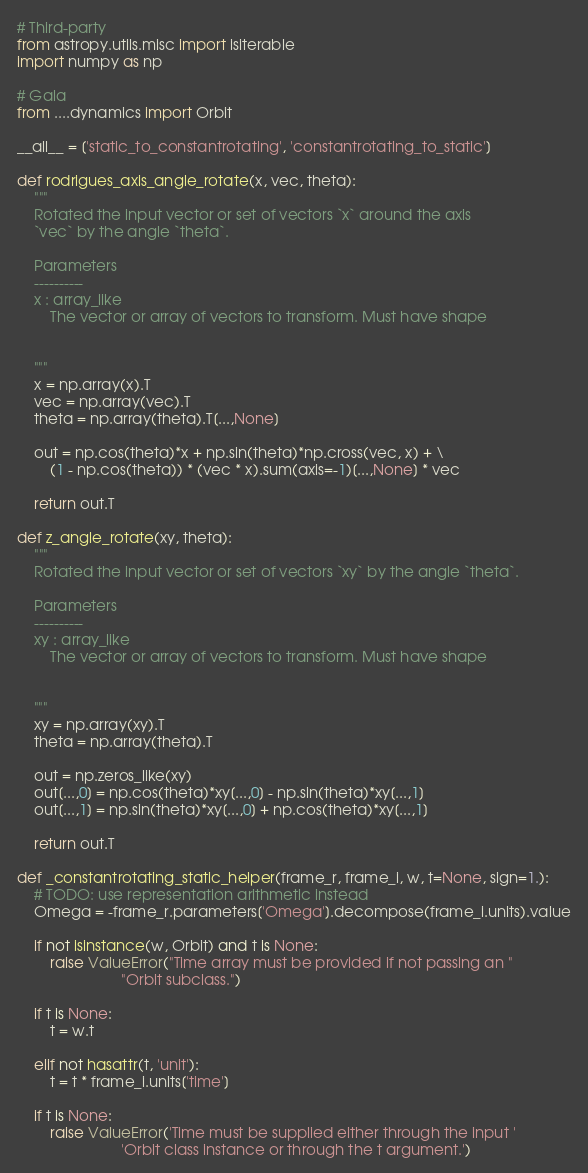<code> <loc_0><loc_0><loc_500><loc_500><_Python_># Third-party
from astropy.utils.misc import isiterable
import numpy as np

# Gala
from ....dynamics import Orbit

__all__ = ['static_to_constantrotating', 'constantrotating_to_static']

def rodrigues_axis_angle_rotate(x, vec, theta):
    """
    Rotated the input vector or set of vectors `x` around the axis
    `vec` by the angle `theta`.

    Parameters
    ----------
    x : array_like
        The vector or array of vectors to transform. Must have shape


    """
    x = np.array(x).T
    vec = np.array(vec).T
    theta = np.array(theta).T[...,None]

    out = np.cos(theta)*x + np.sin(theta)*np.cross(vec, x) + \
        (1 - np.cos(theta)) * (vec * x).sum(axis=-1)[...,None] * vec

    return out.T

def z_angle_rotate(xy, theta):
    """
    Rotated the input vector or set of vectors `xy` by the angle `theta`.

    Parameters
    ----------
    xy : array_like
        The vector or array of vectors to transform. Must have shape


    """
    xy = np.array(xy).T
    theta = np.array(theta).T

    out = np.zeros_like(xy)
    out[...,0] = np.cos(theta)*xy[...,0] - np.sin(theta)*xy[...,1]
    out[...,1] = np.sin(theta)*xy[...,0] + np.cos(theta)*xy[...,1]

    return out.T

def _constantrotating_static_helper(frame_r, frame_i, w, t=None, sign=1.):
    # TODO: use representation arithmetic instead
    Omega = -frame_r.parameters['Omega'].decompose(frame_i.units).value

    if not isinstance(w, Orbit) and t is None:
        raise ValueError("Time array must be provided if not passing an "
                         "Orbit subclass.")

    if t is None:
        t = w.t

    elif not hasattr(t, 'unit'):
        t = t * frame_i.units['time']

    if t is None:
        raise ValueError('Time must be supplied either through the input '
                         'Orbit class instance or through the t argument.')</code> 